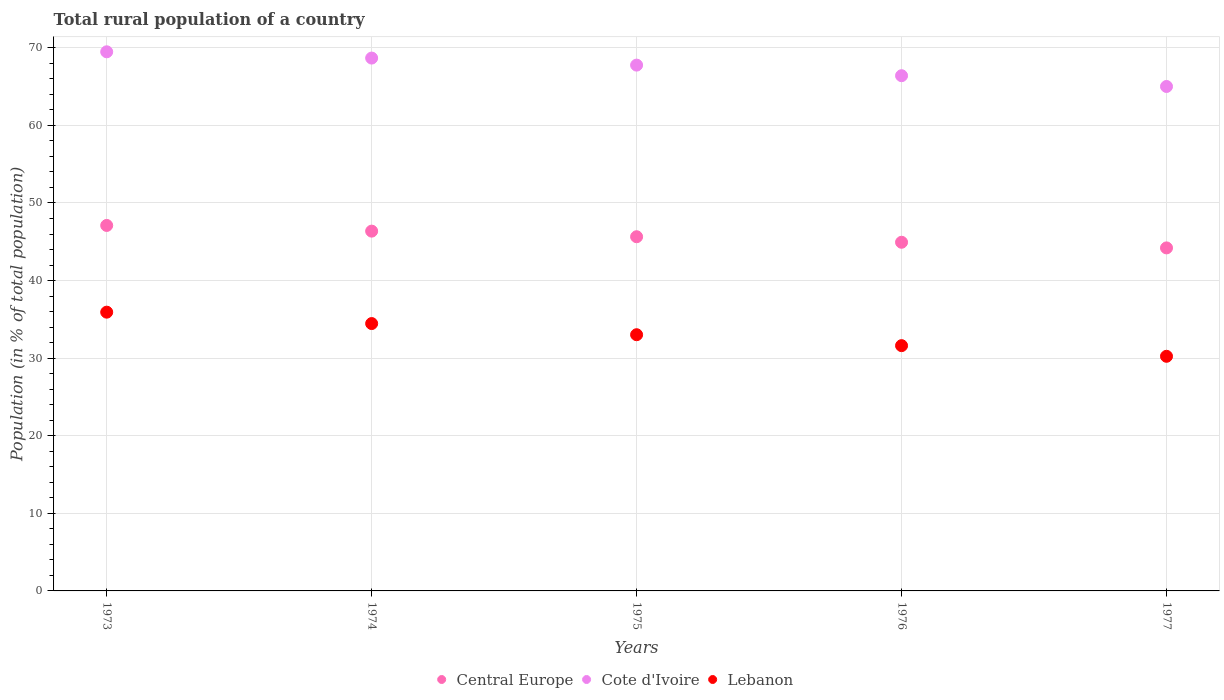What is the rural population in Central Europe in 1976?
Provide a succinct answer. 44.94. Across all years, what is the maximum rural population in Lebanon?
Make the answer very short. 35.93. Across all years, what is the minimum rural population in Lebanon?
Offer a very short reply. 30.24. In which year was the rural population in Central Europe maximum?
Your answer should be compact. 1973. What is the total rural population in Lebanon in the graph?
Your response must be concise. 165.26. What is the difference between the rural population in Lebanon in 1975 and that in 1976?
Your answer should be very brief. 1.41. What is the difference between the rural population in Lebanon in 1975 and the rural population in Cote d'Ivoire in 1974?
Provide a succinct answer. -35.66. What is the average rural population in Central Europe per year?
Offer a very short reply. 45.66. In the year 1973, what is the difference between the rural population in Central Europe and rural population in Cote d'Ivoire?
Give a very brief answer. -22.38. In how many years, is the rural population in Lebanon greater than 46 %?
Your response must be concise. 0. What is the ratio of the rural population in Lebanon in 1975 to that in 1977?
Ensure brevity in your answer.  1.09. Is the rural population in Lebanon in 1973 less than that in 1977?
Your answer should be very brief. No. What is the difference between the highest and the second highest rural population in Central Europe?
Keep it short and to the point. 0.73. What is the difference between the highest and the lowest rural population in Lebanon?
Your answer should be compact. 5.69. Is the sum of the rural population in Lebanon in 1975 and 1977 greater than the maximum rural population in Central Europe across all years?
Provide a succinct answer. Yes. Is the rural population in Central Europe strictly greater than the rural population in Lebanon over the years?
Your answer should be compact. Yes. Is the rural population in Lebanon strictly less than the rural population in Cote d'Ivoire over the years?
Offer a very short reply. Yes. Are the values on the major ticks of Y-axis written in scientific E-notation?
Give a very brief answer. No. Does the graph contain any zero values?
Provide a succinct answer. No. How are the legend labels stacked?
Your answer should be compact. Horizontal. What is the title of the graph?
Offer a very short reply. Total rural population of a country. What is the label or title of the X-axis?
Provide a short and direct response. Years. What is the label or title of the Y-axis?
Provide a short and direct response. Population (in % of total population). What is the Population (in % of total population) in Central Europe in 1973?
Keep it short and to the point. 47.11. What is the Population (in % of total population) of Cote d'Ivoire in 1973?
Offer a very short reply. 69.49. What is the Population (in % of total population) of Lebanon in 1973?
Keep it short and to the point. 35.93. What is the Population (in % of total population) in Central Europe in 1974?
Your answer should be very brief. 46.37. What is the Population (in % of total population) in Cote d'Ivoire in 1974?
Your response must be concise. 68.68. What is the Population (in % of total population) of Lebanon in 1974?
Make the answer very short. 34.46. What is the Population (in % of total population) of Central Europe in 1975?
Give a very brief answer. 45.65. What is the Population (in % of total population) in Cote d'Ivoire in 1975?
Offer a terse response. 67.77. What is the Population (in % of total population) of Lebanon in 1975?
Your answer should be very brief. 33.02. What is the Population (in % of total population) of Central Europe in 1976?
Your response must be concise. 44.94. What is the Population (in % of total population) in Cote d'Ivoire in 1976?
Offer a terse response. 66.41. What is the Population (in % of total population) in Lebanon in 1976?
Offer a terse response. 31.61. What is the Population (in % of total population) in Central Europe in 1977?
Offer a terse response. 44.21. What is the Population (in % of total population) in Cote d'Ivoire in 1977?
Provide a succinct answer. 65.02. What is the Population (in % of total population) of Lebanon in 1977?
Ensure brevity in your answer.  30.24. Across all years, what is the maximum Population (in % of total population) in Central Europe?
Ensure brevity in your answer.  47.11. Across all years, what is the maximum Population (in % of total population) of Cote d'Ivoire?
Your answer should be very brief. 69.49. Across all years, what is the maximum Population (in % of total population) of Lebanon?
Provide a short and direct response. 35.93. Across all years, what is the minimum Population (in % of total population) in Central Europe?
Provide a short and direct response. 44.21. Across all years, what is the minimum Population (in % of total population) of Cote d'Ivoire?
Make the answer very short. 65.02. Across all years, what is the minimum Population (in % of total population) of Lebanon?
Your response must be concise. 30.24. What is the total Population (in % of total population) of Central Europe in the graph?
Make the answer very short. 228.28. What is the total Population (in % of total population) of Cote d'Ivoire in the graph?
Your answer should be compact. 337.36. What is the total Population (in % of total population) in Lebanon in the graph?
Your answer should be compact. 165.26. What is the difference between the Population (in % of total population) in Central Europe in 1973 and that in 1974?
Your response must be concise. 0.73. What is the difference between the Population (in % of total population) in Cote d'Ivoire in 1973 and that in 1974?
Your answer should be compact. 0.81. What is the difference between the Population (in % of total population) of Lebanon in 1973 and that in 1974?
Offer a terse response. 1.47. What is the difference between the Population (in % of total population) of Central Europe in 1973 and that in 1975?
Ensure brevity in your answer.  1.46. What is the difference between the Population (in % of total population) in Cote d'Ivoire in 1973 and that in 1975?
Make the answer very short. 1.72. What is the difference between the Population (in % of total population) in Lebanon in 1973 and that in 1975?
Ensure brevity in your answer.  2.91. What is the difference between the Population (in % of total population) of Central Europe in 1973 and that in 1976?
Keep it short and to the point. 2.17. What is the difference between the Population (in % of total population) in Cote d'Ivoire in 1973 and that in 1976?
Ensure brevity in your answer.  3.08. What is the difference between the Population (in % of total population) in Lebanon in 1973 and that in 1976?
Keep it short and to the point. 4.32. What is the difference between the Population (in % of total population) in Central Europe in 1973 and that in 1977?
Your answer should be compact. 2.89. What is the difference between the Population (in % of total population) of Cote d'Ivoire in 1973 and that in 1977?
Keep it short and to the point. 4.47. What is the difference between the Population (in % of total population) of Lebanon in 1973 and that in 1977?
Give a very brief answer. 5.69. What is the difference between the Population (in % of total population) in Central Europe in 1974 and that in 1975?
Your answer should be compact. 0.72. What is the difference between the Population (in % of total population) in Cote d'Ivoire in 1974 and that in 1975?
Your response must be concise. 0.91. What is the difference between the Population (in % of total population) in Lebanon in 1974 and that in 1975?
Offer a terse response. 1.44. What is the difference between the Population (in % of total population) in Central Europe in 1974 and that in 1976?
Provide a short and direct response. 1.43. What is the difference between the Population (in % of total population) in Cote d'Ivoire in 1974 and that in 1976?
Your response must be concise. 2.27. What is the difference between the Population (in % of total population) of Lebanon in 1974 and that in 1976?
Ensure brevity in your answer.  2.85. What is the difference between the Population (in % of total population) in Central Europe in 1974 and that in 1977?
Your answer should be very brief. 2.16. What is the difference between the Population (in % of total population) in Cote d'Ivoire in 1974 and that in 1977?
Your response must be concise. 3.66. What is the difference between the Population (in % of total population) in Lebanon in 1974 and that in 1977?
Keep it short and to the point. 4.22. What is the difference between the Population (in % of total population) of Central Europe in 1975 and that in 1976?
Offer a terse response. 0.71. What is the difference between the Population (in % of total population) in Cote d'Ivoire in 1975 and that in 1976?
Offer a very short reply. 1.36. What is the difference between the Population (in % of total population) of Lebanon in 1975 and that in 1976?
Keep it short and to the point. 1.41. What is the difference between the Population (in % of total population) of Central Europe in 1975 and that in 1977?
Make the answer very short. 1.44. What is the difference between the Population (in % of total population) in Cote d'Ivoire in 1975 and that in 1977?
Provide a succinct answer. 2.75. What is the difference between the Population (in % of total population) in Lebanon in 1975 and that in 1977?
Provide a short and direct response. 2.78. What is the difference between the Population (in % of total population) of Central Europe in 1976 and that in 1977?
Ensure brevity in your answer.  0.73. What is the difference between the Population (in % of total population) of Cote d'Ivoire in 1976 and that in 1977?
Provide a succinct answer. 1.39. What is the difference between the Population (in % of total population) of Lebanon in 1976 and that in 1977?
Your response must be concise. 1.37. What is the difference between the Population (in % of total population) in Central Europe in 1973 and the Population (in % of total population) in Cote d'Ivoire in 1974?
Keep it short and to the point. -21.57. What is the difference between the Population (in % of total population) in Central Europe in 1973 and the Population (in % of total population) in Lebanon in 1974?
Keep it short and to the point. 12.65. What is the difference between the Population (in % of total population) in Cote d'Ivoire in 1973 and the Population (in % of total population) in Lebanon in 1974?
Provide a succinct answer. 35.03. What is the difference between the Population (in % of total population) in Central Europe in 1973 and the Population (in % of total population) in Cote d'Ivoire in 1975?
Offer a very short reply. -20.67. What is the difference between the Population (in % of total population) of Central Europe in 1973 and the Population (in % of total population) of Lebanon in 1975?
Offer a very short reply. 14.08. What is the difference between the Population (in % of total population) in Cote d'Ivoire in 1973 and the Population (in % of total population) in Lebanon in 1975?
Your answer should be very brief. 36.47. What is the difference between the Population (in % of total population) in Central Europe in 1973 and the Population (in % of total population) in Cote d'Ivoire in 1976?
Your response must be concise. -19.3. What is the difference between the Population (in % of total population) of Central Europe in 1973 and the Population (in % of total population) of Lebanon in 1976?
Keep it short and to the point. 15.49. What is the difference between the Population (in % of total population) of Cote d'Ivoire in 1973 and the Population (in % of total population) of Lebanon in 1976?
Your answer should be very brief. 37.87. What is the difference between the Population (in % of total population) of Central Europe in 1973 and the Population (in % of total population) of Cote d'Ivoire in 1977?
Your answer should be very brief. -17.91. What is the difference between the Population (in % of total population) of Central Europe in 1973 and the Population (in % of total population) of Lebanon in 1977?
Ensure brevity in your answer.  16.86. What is the difference between the Population (in % of total population) in Cote d'Ivoire in 1973 and the Population (in % of total population) in Lebanon in 1977?
Make the answer very short. 39.25. What is the difference between the Population (in % of total population) of Central Europe in 1974 and the Population (in % of total population) of Cote d'Ivoire in 1975?
Keep it short and to the point. -21.4. What is the difference between the Population (in % of total population) in Central Europe in 1974 and the Population (in % of total population) in Lebanon in 1975?
Ensure brevity in your answer.  13.35. What is the difference between the Population (in % of total population) in Cote d'Ivoire in 1974 and the Population (in % of total population) in Lebanon in 1975?
Provide a short and direct response. 35.66. What is the difference between the Population (in % of total population) of Central Europe in 1974 and the Population (in % of total population) of Cote d'Ivoire in 1976?
Make the answer very short. -20.03. What is the difference between the Population (in % of total population) in Central Europe in 1974 and the Population (in % of total population) in Lebanon in 1976?
Your answer should be very brief. 14.76. What is the difference between the Population (in % of total population) in Cote d'Ivoire in 1974 and the Population (in % of total population) in Lebanon in 1976?
Keep it short and to the point. 37.07. What is the difference between the Population (in % of total population) of Central Europe in 1974 and the Population (in % of total population) of Cote d'Ivoire in 1977?
Offer a very short reply. -18.64. What is the difference between the Population (in % of total population) in Central Europe in 1974 and the Population (in % of total population) in Lebanon in 1977?
Offer a terse response. 16.13. What is the difference between the Population (in % of total population) in Cote d'Ivoire in 1974 and the Population (in % of total population) in Lebanon in 1977?
Provide a short and direct response. 38.44. What is the difference between the Population (in % of total population) in Central Europe in 1975 and the Population (in % of total population) in Cote d'Ivoire in 1976?
Offer a terse response. -20.76. What is the difference between the Population (in % of total population) of Central Europe in 1975 and the Population (in % of total population) of Lebanon in 1976?
Make the answer very short. 14.04. What is the difference between the Population (in % of total population) in Cote d'Ivoire in 1975 and the Population (in % of total population) in Lebanon in 1976?
Provide a succinct answer. 36.16. What is the difference between the Population (in % of total population) in Central Europe in 1975 and the Population (in % of total population) in Cote d'Ivoire in 1977?
Your response must be concise. -19.37. What is the difference between the Population (in % of total population) of Central Europe in 1975 and the Population (in % of total population) of Lebanon in 1977?
Make the answer very short. 15.41. What is the difference between the Population (in % of total population) of Cote d'Ivoire in 1975 and the Population (in % of total population) of Lebanon in 1977?
Provide a succinct answer. 37.53. What is the difference between the Population (in % of total population) in Central Europe in 1976 and the Population (in % of total population) in Cote d'Ivoire in 1977?
Give a very brief answer. -20.08. What is the difference between the Population (in % of total population) in Central Europe in 1976 and the Population (in % of total population) in Lebanon in 1977?
Provide a short and direct response. 14.7. What is the difference between the Population (in % of total population) of Cote d'Ivoire in 1976 and the Population (in % of total population) of Lebanon in 1977?
Keep it short and to the point. 36.16. What is the average Population (in % of total population) of Central Europe per year?
Keep it short and to the point. 45.66. What is the average Population (in % of total population) in Cote d'Ivoire per year?
Ensure brevity in your answer.  67.47. What is the average Population (in % of total population) in Lebanon per year?
Your answer should be very brief. 33.05. In the year 1973, what is the difference between the Population (in % of total population) in Central Europe and Population (in % of total population) in Cote d'Ivoire?
Provide a succinct answer. -22.38. In the year 1973, what is the difference between the Population (in % of total population) in Central Europe and Population (in % of total population) in Lebanon?
Your answer should be compact. 11.18. In the year 1973, what is the difference between the Population (in % of total population) in Cote d'Ivoire and Population (in % of total population) in Lebanon?
Keep it short and to the point. 33.56. In the year 1974, what is the difference between the Population (in % of total population) in Central Europe and Population (in % of total population) in Cote d'Ivoire?
Your answer should be very brief. -22.31. In the year 1974, what is the difference between the Population (in % of total population) in Central Europe and Population (in % of total population) in Lebanon?
Provide a short and direct response. 11.91. In the year 1974, what is the difference between the Population (in % of total population) in Cote d'Ivoire and Population (in % of total population) in Lebanon?
Offer a very short reply. 34.22. In the year 1975, what is the difference between the Population (in % of total population) of Central Europe and Population (in % of total population) of Cote d'Ivoire?
Your answer should be very brief. -22.12. In the year 1975, what is the difference between the Population (in % of total population) in Central Europe and Population (in % of total population) in Lebanon?
Make the answer very short. 12.63. In the year 1975, what is the difference between the Population (in % of total population) of Cote d'Ivoire and Population (in % of total population) of Lebanon?
Give a very brief answer. 34.75. In the year 1976, what is the difference between the Population (in % of total population) of Central Europe and Population (in % of total population) of Cote d'Ivoire?
Your answer should be very brief. -21.47. In the year 1976, what is the difference between the Population (in % of total population) in Central Europe and Population (in % of total population) in Lebanon?
Provide a succinct answer. 13.33. In the year 1976, what is the difference between the Population (in % of total population) of Cote d'Ivoire and Population (in % of total population) of Lebanon?
Offer a terse response. 34.79. In the year 1977, what is the difference between the Population (in % of total population) in Central Europe and Population (in % of total population) in Cote d'Ivoire?
Offer a terse response. -20.81. In the year 1977, what is the difference between the Population (in % of total population) of Central Europe and Population (in % of total population) of Lebanon?
Provide a succinct answer. 13.97. In the year 1977, what is the difference between the Population (in % of total population) in Cote d'Ivoire and Population (in % of total population) in Lebanon?
Your answer should be very brief. 34.78. What is the ratio of the Population (in % of total population) of Central Europe in 1973 to that in 1974?
Provide a succinct answer. 1.02. What is the ratio of the Population (in % of total population) of Cote d'Ivoire in 1973 to that in 1974?
Your answer should be very brief. 1.01. What is the ratio of the Population (in % of total population) of Lebanon in 1973 to that in 1974?
Ensure brevity in your answer.  1.04. What is the ratio of the Population (in % of total population) of Central Europe in 1973 to that in 1975?
Provide a succinct answer. 1.03. What is the ratio of the Population (in % of total population) of Cote d'Ivoire in 1973 to that in 1975?
Make the answer very short. 1.03. What is the ratio of the Population (in % of total population) of Lebanon in 1973 to that in 1975?
Keep it short and to the point. 1.09. What is the ratio of the Population (in % of total population) of Central Europe in 1973 to that in 1976?
Your answer should be very brief. 1.05. What is the ratio of the Population (in % of total population) of Cote d'Ivoire in 1973 to that in 1976?
Provide a succinct answer. 1.05. What is the ratio of the Population (in % of total population) in Lebanon in 1973 to that in 1976?
Your answer should be compact. 1.14. What is the ratio of the Population (in % of total population) of Central Europe in 1973 to that in 1977?
Offer a very short reply. 1.07. What is the ratio of the Population (in % of total population) in Cote d'Ivoire in 1973 to that in 1977?
Provide a succinct answer. 1.07. What is the ratio of the Population (in % of total population) of Lebanon in 1973 to that in 1977?
Give a very brief answer. 1.19. What is the ratio of the Population (in % of total population) in Central Europe in 1974 to that in 1975?
Make the answer very short. 1.02. What is the ratio of the Population (in % of total population) of Cote d'Ivoire in 1974 to that in 1975?
Give a very brief answer. 1.01. What is the ratio of the Population (in % of total population) in Lebanon in 1974 to that in 1975?
Your answer should be very brief. 1.04. What is the ratio of the Population (in % of total population) in Central Europe in 1974 to that in 1976?
Your response must be concise. 1.03. What is the ratio of the Population (in % of total population) in Cote d'Ivoire in 1974 to that in 1976?
Keep it short and to the point. 1.03. What is the ratio of the Population (in % of total population) of Lebanon in 1974 to that in 1976?
Make the answer very short. 1.09. What is the ratio of the Population (in % of total population) of Central Europe in 1974 to that in 1977?
Your response must be concise. 1.05. What is the ratio of the Population (in % of total population) in Cote d'Ivoire in 1974 to that in 1977?
Offer a very short reply. 1.06. What is the ratio of the Population (in % of total population) of Lebanon in 1974 to that in 1977?
Provide a succinct answer. 1.14. What is the ratio of the Population (in % of total population) in Central Europe in 1975 to that in 1976?
Give a very brief answer. 1.02. What is the ratio of the Population (in % of total population) of Cote d'Ivoire in 1975 to that in 1976?
Your answer should be very brief. 1.02. What is the ratio of the Population (in % of total population) of Lebanon in 1975 to that in 1976?
Offer a terse response. 1.04. What is the ratio of the Population (in % of total population) of Central Europe in 1975 to that in 1977?
Your answer should be very brief. 1.03. What is the ratio of the Population (in % of total population) of Cote d'Ivoire in 1975 to that in 1977?
Your response must be concise. 1.04. What is the ratio of the Population (in % of total population) of Lebanon in 1975 to that in 1977?
Provide a short and direct response. 1.09. What is the ratio of the Population (in % of total population) in Central Europe in 1976 to that in 1977?
Offer a terse response. 1.02. What is the ratio of the Population (in % of total population) of Cote d'Ivoire in 1976 to that in 1977?
Provide a succinct answer. 1.02. What is the ratio of the Population (in % of total population) in Lebanon in 1976 to that in 1977?
Your answer should be very brief. 1.05. What is the difference between the highest and the second highest Population (in % of total population) in Central Europe?
Provide a short and direct response. 0.73. What is the difference between the highest and the second highest Population (in % of total population) of Cote d'Ivoire?
Make the answer very short. 0.81. What is the difference between the highest and the second highest Population (in % of total population) in Lebanon?
Your answer should be compact. 1.47. What is the difference between the highest and the lowest Population (in % of total population) of Central Europe?
Give a very brief answer. 2.89. What is the difference between the highest and the lowest Population (in % of total population) of Cote d'Ivoire?
Offer a terse response. 4.47. What is the difference between the highest and the lowest Population (in % of total population) in Lebanon?
Give a very brief answer. 5.69. 